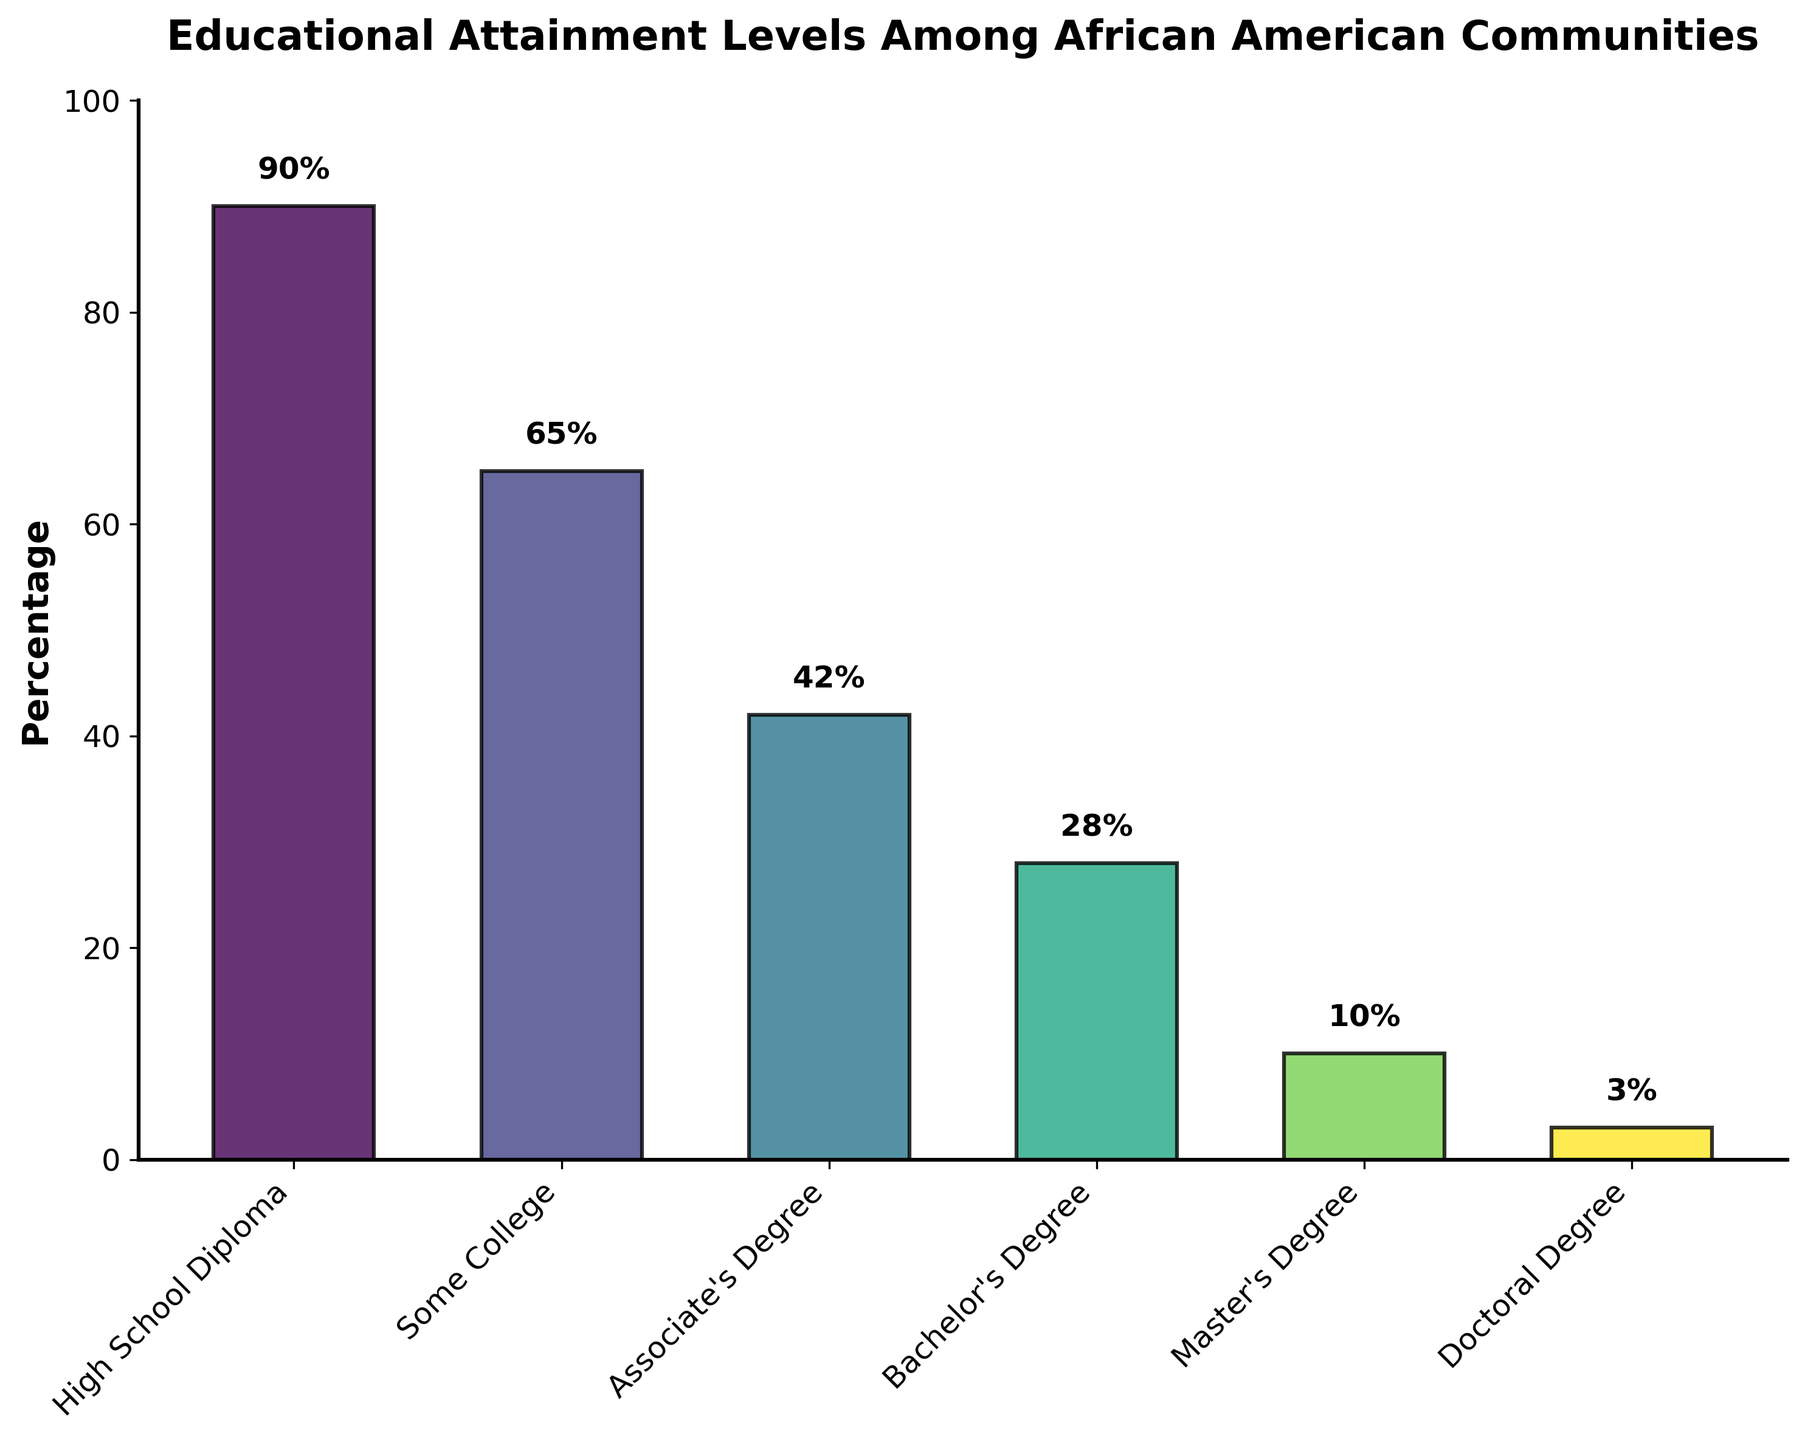What is the overall title of the figure? The title is written at the top of the chart and is "Educational Attainment Levels Among African American Communities".
Answer: Educational Attainment Levels Among African American Communities What is the percentage of African Americans with a Master's Degree? The bar labeled "Master's Degree" on the chart indicates this percentage, and the number above the bar confirms it is 10%.
Answer: 10% Which educational level has the highest percentage? By observing the lengths of the bars, the "High School Diploma" bar is the highest, indicating it has the highest percentage.
Answer: High School Diploma How much higher is the percentage of people with a Bachelor's Degree compared to those with a Doctoral Degree? The Bachelor's Degree bar shows 28%, and the Doctoral Degree bar shows 3%. The difference is calculated as 28% - 3% = 25%.
Answer: 25% What is the difference between the percentage of those with an Associate's Degree and those with some college education? The chart indicates 42% for Associate's Degree and 65% for some college education. The difference is 65% - 42% = 23%.
Answer: 23% What's the combined percentage of African Americans with either a Master's or Doctoral Degree? Master’s Degree percentage is 10% and Doctoral Degree percentage is 3%. Summing them gives 10% + 3% = 13%.
Answer: 13% Rank the educational attainment levels from highest to lowest percentage. By comparing the heights of the bars, the order from highest to lowest percentage is: High School Diploma, Some College, Associate's Degree, Bachelor’s Degree, Master’s Degree, Doctoral Degree.
Answer: High School Diploma, Some College, Associate's Degree, Bachelor's Degree, Master's Degree, Doctoral Degree What percentage of people have at least a Bachelor's Degree? Adding the percentages for Bachelor's Degree (28%), Master's Degree (10%), and Doctoral Degree (3%) yields 28% + 10% + 3% = 41%.
Answer: 41% Which educational level has the smallest percentage? The shortest bar on the chart corresponds to "Doctoral Degree", which has 3%.
Answer: Doctoral Degree How does the percentage of individuals with some college compare to those with an Associate's Degree? The percentage for some college is 65%, while for Associate's Degree it is 42%. The percentage for some college is higher by 23%.
Answer: Some College is 23% higher 